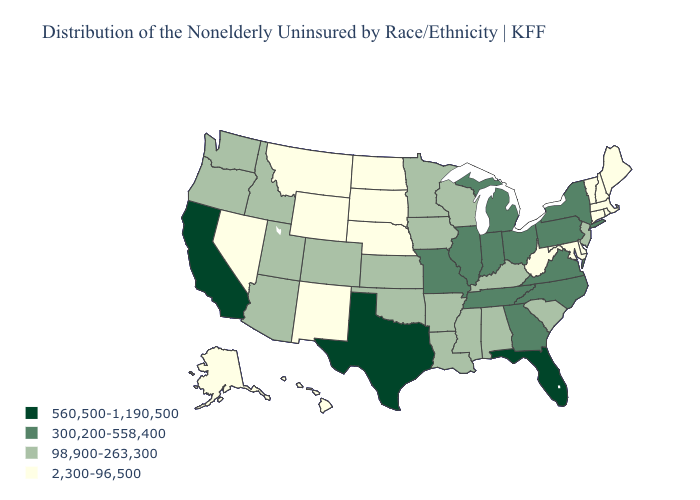What is the value of Minnesota?
Short answer required. 98,900-263,300. Name the states that have a value in the range 560,500-1,190,500?
Quick response, please. California, Florida, Texas. What is the lowest value in the South?
Keep it brief. 2,300-96,500. What is the value of Wyoming?
Quick response, please. 2,300-96,500. Among the states that border North Carolina , which have the highest value?
Short answer required. Georgia, Tennessee, Virginia. Does Massachusetts have the lowest value in the Northeast?
Quick response, please. Yes. Name the states that have a value in the range 560,500-1,190,500?
Keep it brief. California, Florida, Texas. What is the highest value in the West ?
Short answer required. 560,500-1,190,500. What is the value of Utah?
Short answer required. 98,900-263,300. What is the highest value in states that border Ohio?
Give a very brief answer. 300,200-558,400. What is the value of California?
Quick response, please. 560,500-1,190,500. Does Idaho have the lowest value in the USA?
Short answer required. No. What is the lowest value in states that border Maryland?
Give a very brief answer. 2,300-96,500. What is the highest value in the USA?
Concise answer only. 560,500-1,190,500. What is the value of Michigan?
Give a very brief answer. 300,200-558,400. 